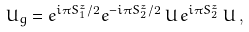Convert formula to latex. <formula><loc_0><loc_0><loc_500><loc_500>U _ { g } = e ^ { i \pi S _ { 1 } ^ { z } / 2 } e ^ { - i \pi S _ { 2 } ^ { z } / 2 } \, U \, e ^ { i \pi S _ { 2 } ^ { z } } \, U \, ,</formula> 